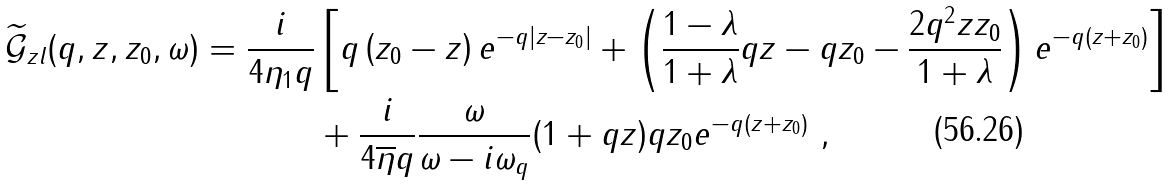Convert formula to latex. <formula><loc_0><loc_0><loc_500><loc_500>\widetilde { \mathcal { G } } _ { z l } ( q , z , z _ { 0 } , \omega ) = \frac { i } { 4 \eta _ { 1 } q } & \left [ q \left ( z _ { 0 } - z \right ) e ^ { - q | z - z _ { 0 } | } + \left ( \frac { 1 - \lambda } { 1 + \lambda } q z - q z _ { 0 } - \frac { 2 q ^ { 2 } z z _ { 0 } } { 1 + \lambda } \right ) e ^ { - q ( z + z _ { 0 } ) } \right ] \\ & + \frac { i } { 4 \overline { \eta } q } \frac { \omega } { \omega - i \omega _ { q } } ( 1 + q z ) q z _ { 0 } e ^ { - q ( z + z _ { 0 } ) } \ ,</formula> 